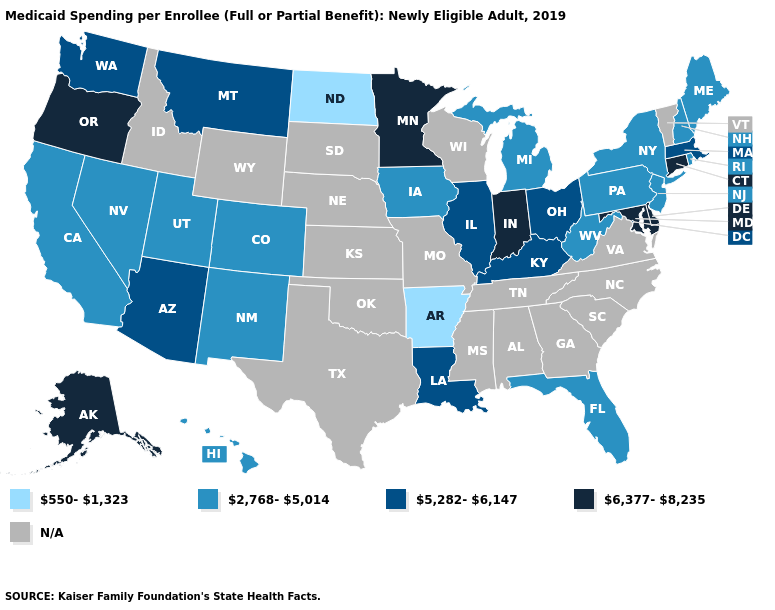Which states have the lowest value in the West?
Write a very short answer. California, Colorado, Hawaii, Nevada, New Mexico, Utah. Name the states that have a value in the range N/A?
Write a very short answer. Alabama, Georgia, Idaho, Kansas, Mississippi, Missouri, Nebraska, North Carolina, Oklahoma, South Carolina, South Dakota, Tennessee, Texas, Vermont, Virginia, Wisconsin, Wyoming. Name the states that have a value in the range N/A?
Concise answer only. Alabama, Georgia, Idaho, Kansas, Mississippi, Missouri, Nebraska, North Carolina, Oklahoma, South Carolina, South Dakota, Tennessee, Texas, Vermont, Virginia, Wisconsin, Wyoming. Does West Virginia have the lowest value in the South?
Write a very short answer. No. Does Arizona have the lowest value in the USA?
Concise answer only. No. What is the value of Wisconsin?
Keep it brief. N/A. Among the states that border Wyoming , which have the lowest value?
Short answer required. Colorado, Utah. Among the states that border Wisconsin , does Minnesota have the highest value?
Write a very short answer. Yes. What is the value of Kansas?
Be succinct. N/A. Name the states that have a value in the range N/A?
Short answer required. Alabama, Georgia, Idaho, Kansas, Mississippi, Missouri, Nebraska, North Carolina, Oklahoma, South Carolina, South Dakota, Tennessee, Texas, Vermont, Virginia, Wisconsin, Wyoming. What is the value of West Virginia?
Concise answer only. 2,768-5,014. Among the states that border Kentucky , does Indiana have the lowest value?
Give a very brief answer. No. What is the value of Montana?
Quick response, please. 5,282-6,147. What is the value of South Dakota?
Keep it brief. N/A. 